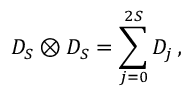Convert formula to latex. <formula><loc_0><loc_0><loc_500><loc_500>D _ { S } \otimes D _ { S } = \sum _ { j = 0 } ^ { 2 S } D _ { j } \, ,</formula> 